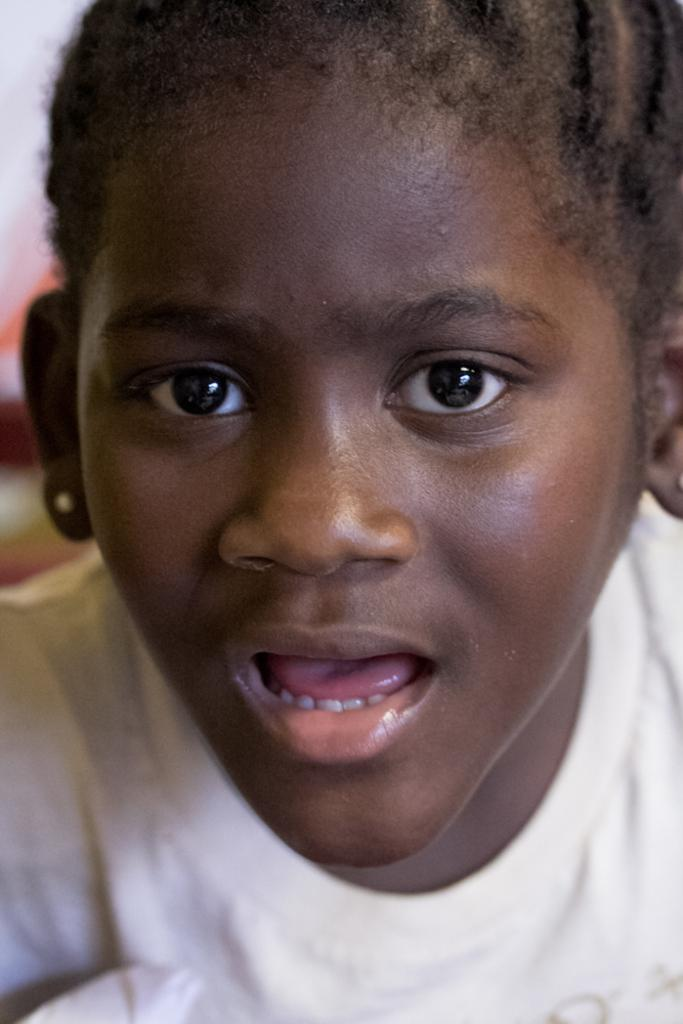How many people are present in the image? There is one person in the image. What type of flowers can be seen in the image? There are no flowers present in the image; it only features one person. Is there a bear visible in the image? No, there is no bear present in the image. 